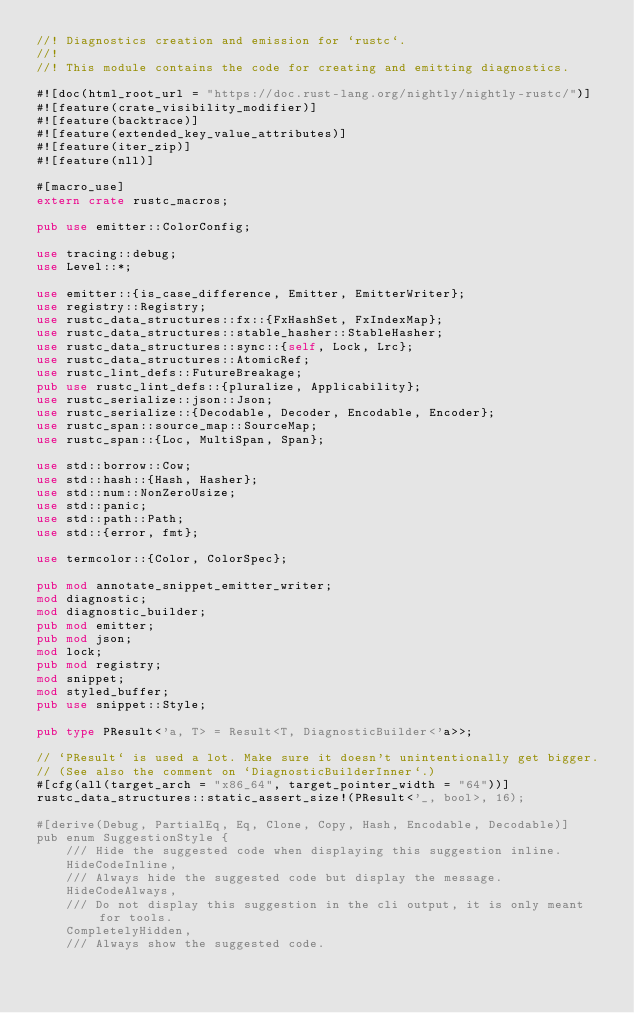<code> <loc_0><loc_0><loc_500><loc_500><_Rust_>//! Diagnostics creation and emission for `rustc`.
//!
//! This module contains the code for creating and emitting diagnostics.

#![doc(html_root_url = "https://doc.rust-lang.org/nightly/nightly-rustc/")]
#![feature(crate_visibility_modifier)]
#![feature(backtrace)]
#![feature(extended_key_value_attributes)]
#![feature(iter_zip)]
#![feature(nll)]

#[macro_use]
extern crate rustc_macros;

pub use emitter::ColorConfig;

use tracing::debug;
use Level::*;

use emitter::{is_case_difference, Emitter, EmitterWriter};
use registry::Registry;
use rustc_data_structures::fx::{FxHashSet, FxIndexMap};
use rustc_data_structures::stable_hasher::StableHasher;
use rustc_data_structures::sync::{self, Lock, Lrc};
use rustc_data_structures::AtomicRef;
use rustc_lint_defs::FutureBreakage;
pub use rustc_lint_defs::{pluralize, Applicability};
use rustc_serialize::json::Json;
use rustc_serialize::{Decodable, Decoder, Encodable, Encoder};
use rustc_span::source_map::SourceMap;
use rustc_span::{Loc, MultiSpan, Span};

use std::borrow::Cow;
use std::hash::{Hash, Hasher};
use std::num::NonZeroUsize;
use std::panic;
use std::path::Path;
use std::{error, fmt};

use termcolor::{Color, ColorSpec};

pub mod annotate_snippet_emitter_writer;
mod diagnostic;
mod diagnostic_builder;
pub mod emitter;
pub mod json;
mod lock;
pub mod registry;
mod snippet;
mod styled_buffer;
pub use snippet::Style;

pub type PResult<'a, T> = Result<T, DiagnosticBuilder<'a>>;

// `PResult` is used a lot. Make sure it doesn't unintentionally get bigger.
// (See also the comment on `DiagnosticBuilderInner`.)
#[cfg(all(target_arch = "x86_64", target_pointer_width = "64"))]
rustc_data_structures::static_assert_size!(PResult<'_, bool>, 16);

#[derive(Debug, PartialEq, Eq, Clone, Copy, Hash, Encodable, Decodable)]
pub enum SuggestionStyle {
    /// Hide the suggested code when displaying this suggestion inline.
    HideCodeInline,
    /// Always hide the suggested code but display the message.
    HideCodeAlways,
    /// Do not display this suggestion in the cli output, it is only meant for tools.
    CompletelyHidden,
    /// Always show the suggested code.</code> 